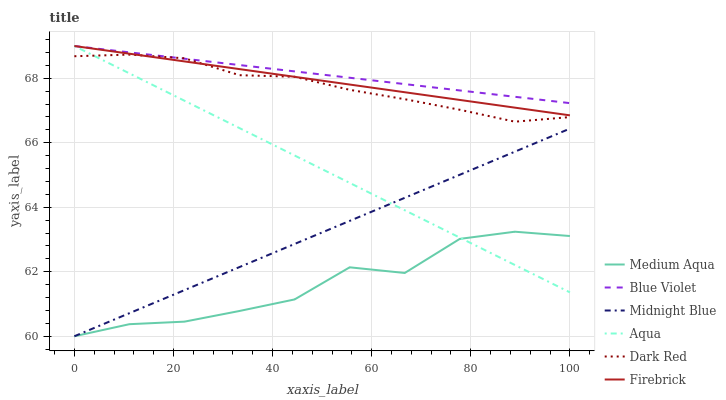Does Medium Aqua have the minimum area under the curve?
Answer yes or no. Yes. Does Blue Violet have the maximum area under the curve?
Answer yes or no. Yes. Does Dark Red have the minimum area under the curve?
Answer yes or no. No. Does Dark Red have the maximum area under the curve?
Answer yes or no. No. Is Midnight Blue the smoothest?
Answer yes or no. Yes. Is Medium Aqua the roughest?
Answer yes or no. Yes. Is Dark Red the smoothest?
Answer yes or no. No. Is Dark Red the roughest?
Answer yes or no. No. Does Midnight Blue have the lowest value?
Answer yes or no. Yes. Does Dark Red have the lowest value?
Answer yes or no. No. Does Blue Violet have the highest value?
Answer yes or no. Yes. Does Dark Red have the highest value?
Answer yes or no. No. Is Midnight Blue less than Blue Violet?
Answer yes or no. Yes. Is Blue Violet greater than Midnight Blue?
Answer yes or no. Yes. Does Blue Violet intersect Dark Red?
Answer yes or no. Yes. Is Blue Violet less than Dark Red?
Answer yes or no. No. Is Blue Violet greater than Dark Red?
Answer yes or no. No. Does Midnight Blue intersect Blue Violet?
Answer yes or no. No. 